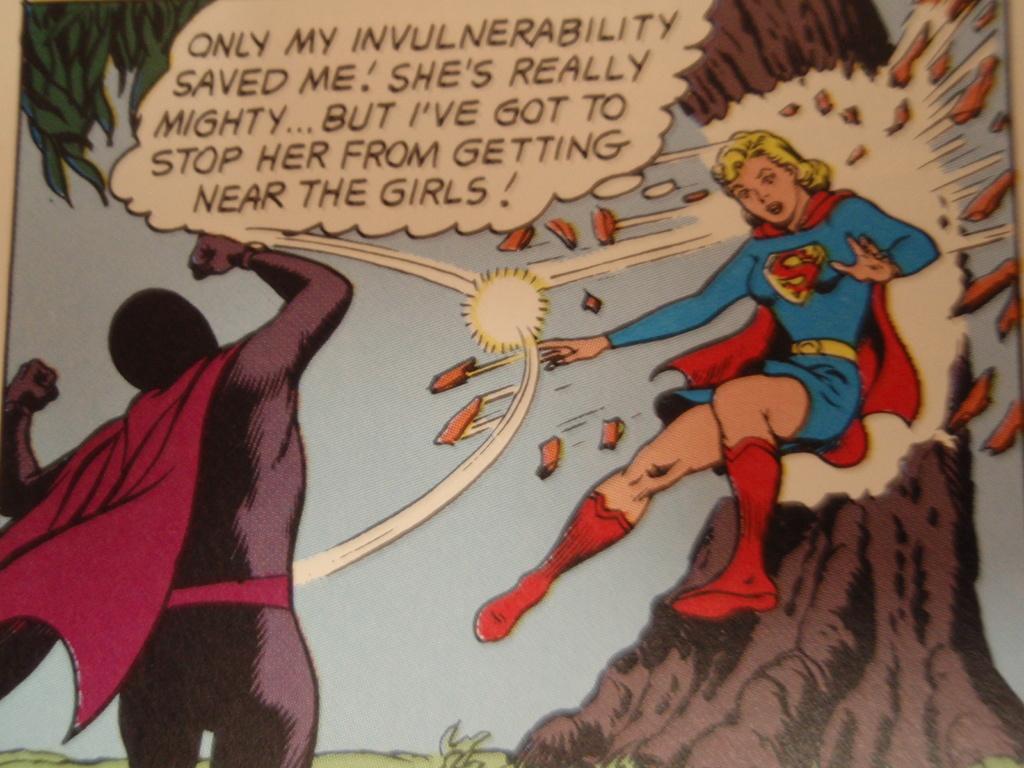In one or two sentences, can you explain what this image depicts? In this image we can see a poster, on the right corner, there is a batman standing, in front there is a super woman, there is some matter written on it, at the back there is a tree. 